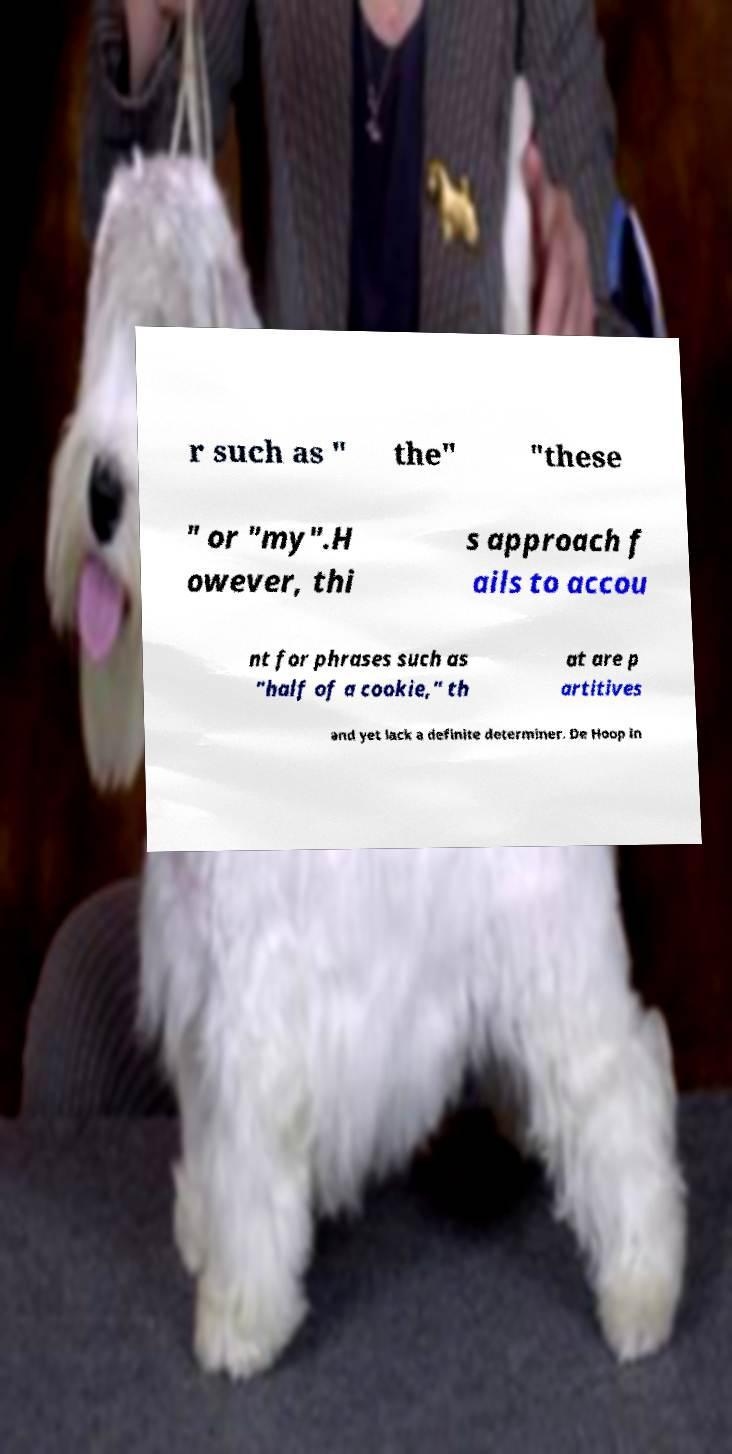For documentation purposes, I need the text within this image transcribed. Could you provide that? r such as " the" "these " or "my".H owever, thi s approach f ails to accou nt for phrases such as "half of a cookie," th at are p artitives and yet lack a definite determiner. De Hoop in 